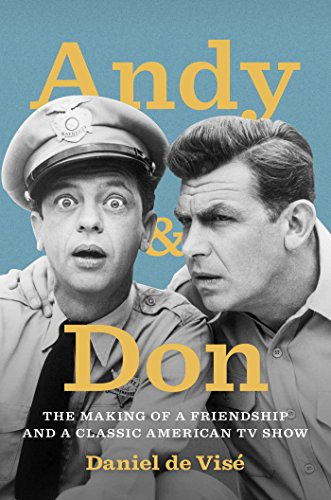What is the title of this book? The full title of this engaging read is 'Andy and Don: The Making of a Friendship and a Classic American TV Show', delving into the personal and professional lives of two of television's most beloved figures. 